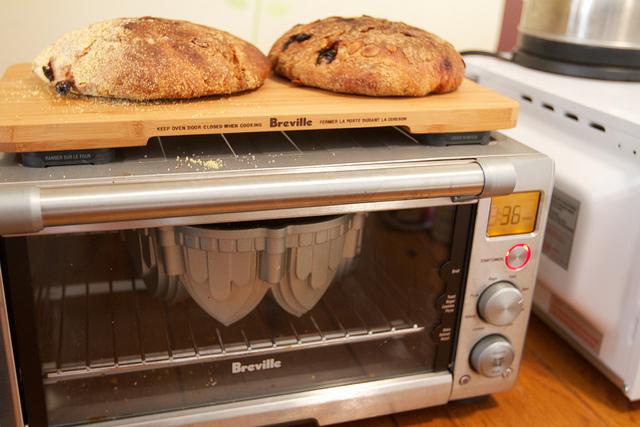What color is the oven?
Concise answer only. Silver. Are the cookies cooked?
Quick response, please. Yes. How many knobs are pictured?
Quick response, please. 2. 